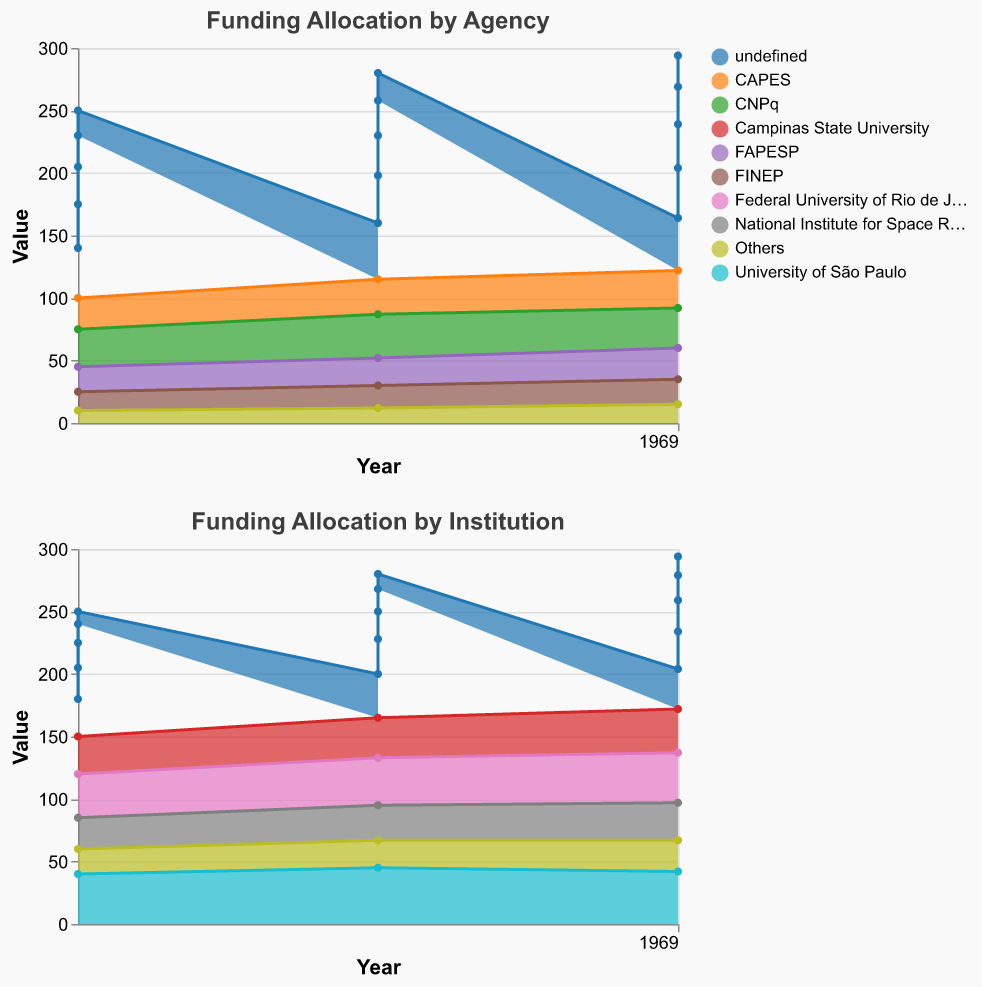What is the total funding allocated by CAPES in 2019? The area chart shows CAPES with a funding value of 28 in 2019.
Answer: 28 Which funding agency received the highest allocation in 2020? Looking at the area chart for 2020, CNPq received a value of 32 indicating the highest allocation.
Answer: CNPq How did the total funding for "Others" change from 2018 to 2020 for both funding agencies and institutions? For funding agencies, "Others" increased from 10 to 15. For institutions, "Others" increased from 20 to 25 between the years 2018 and 2020.
Answer: Increased Which institution saw the greatest increase in funding from 2018 to 2020? By looking at the charts, Campinas State University had an increase from 30 in 2018 to 35 in 2020, which is a 5-unit increase. Although Federal University of Rio de Janeiro also had an increase of 5 units, the highest total funding value increase is more apparent for Campinas State University.
Answer: Campinas State University How does the funding allocation trend for FAPESP compare with FINEP from 2018 to 2020? FAPESP increased from 20 to 25, while FINEP increased from 15 to 20 showing both had an upward trend.
Answer: Both increased What is the combined funding of CNPq and CAPES in 2020? For 2020, CNPq received 32 and CAPES received 30, summing up to 62.
Answer: 62 Which institution had the most consistent funding allocation over the years 2018 to 2020? The University of São Paulo has the least variation with values of 40, 45, and 42, suggesting a consistent trend.
Answer: University of São Paulo From the funding agency data, which year shows the highest total funding allocation across all agencies? Summing up the values for each year: 2018 (30+25+20+15+10 = 100), 2019 (35+28+22+18+12 = 115), 2020 (32+30+25+20+15 = 122). The year 2020 has the highest total.
Answer: 2020 Which institution experienced the smallest increase in funding from 2019 to 2020? The University of São Paulo shows a slight decrease rather than an increase, from 45 in 2019 to 42 in 2020.
Answer: University of São Paulo What was the value for "National Institute for Space Research" in 2019? Based on the area chart, the value is 28 in 2019 for the National Institute for Space Research.
Answer: 28 